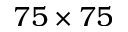Convert formula to latex. <formula><loc_0><loc_0><loc_500><loc_500>7 5 \times 7 5</formula> 